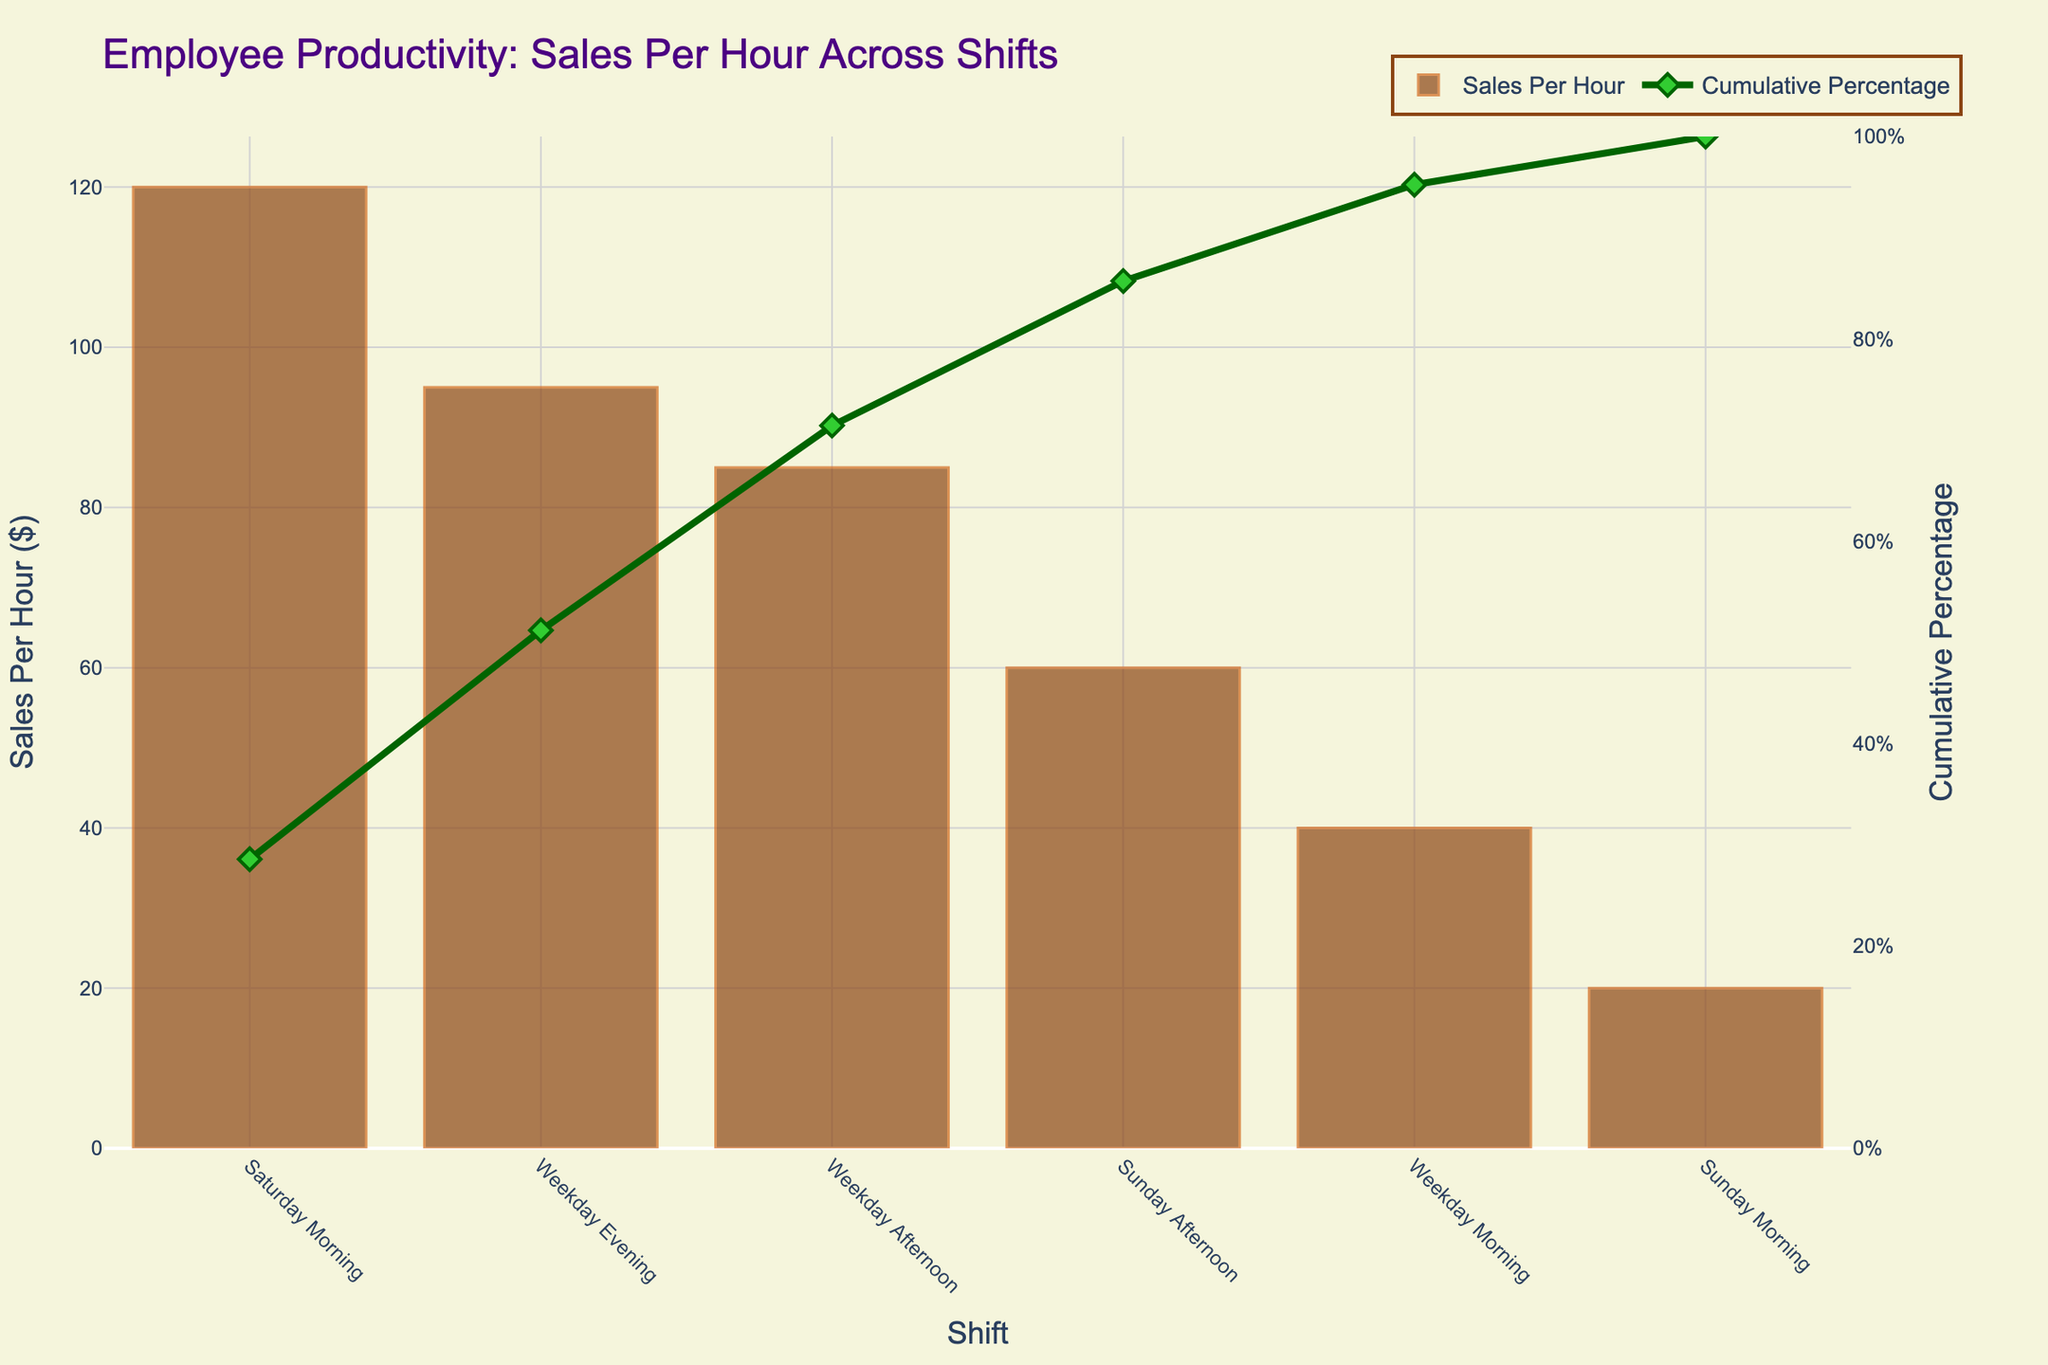What's the title of the chart? The title is displayed at the top of the chart and usually provides a summary of what the chart is about. In this case, the title is "Employee Productivity: Sales Per Hour Across Shifts".
Answer: Employee Productivity: Sales Per Hour Across Shifts Which shift has the highest sales per hour? The highest bar in the chart represents the shift with the highest sales per hour. The bar for "Saturday Morning" is the tallest, indicating the highest productivity in sales per hour.
Answer: Saturday Morning What is the cumulative percentage for the Weekday Morning shift? The line plot shows the cumulative percentage for each shift. By looking at the corresponding point for the Weekday Morning shift on the line plot, we see that it reaches 95.3%.
Answer: 95.3% Which shift contributes to the cumulative percentage reaching 100%? The last data point in the cumulative percentage line plot shows where the cumulative percentage reaches 100%. The point corresponds to the "Sunday Morning" shift.
Answer: Sunday Morning How many shifts have a cumulative percentage above 50%? To answer this, follow the cumulative percentage line and count the number of shifts that have values above 50%. The shifts are Weekday Afternoon, Sunday Afternoon, Weekday Morning, and Sunday Morning, resulting in four shifts.
Answer: 4 What is the sales per hour difference between Saturday Morning and Sunday Morning shifts? The sales per hour for Saturday Morning is 120, and for Sunday Morning, it's 20. The difference is calculated as 120 - 20.
Answer: 100 Which shift has less sales per hour, Weekday Evening or Weekday Afternoon? Compare the heights of the bars for Weekday Evening and Weekday Afternoon. Weekday Afternoon has higher sales per hour than Weekday Evening.
Answer: Weekday Evening What percentage of total sales is contributed by Sunday Afternoon and Sunday Morning shifts combined? The sales per hour for Sunday Afternoon is 60 and for Sunday Morning is 20. Summing these gives 80. The total sales per hour from all shifts is 420. The combined percentage is \( \frac{80}{420} \times 100 \approx 19\% \).
Answer: ~19% What is the average sales per hour for the weekday shifts? The sales per hour for weekday shifts are 95 (Evening), 85 (Afternoon), and 40 (Morning). The sum is 220. There are three shifts, so the average is \( \frac{220}{3} \approx 73.33 \).
Answer: ~73.33 Which shift’s contribution causes the cumulative percentage to exceed 85%? Follow the cumulative percentage line and identify the shift where it exceeds 85%, which is the Weekday Morning shift at 95.3%.
Answer: Weekday Morning 